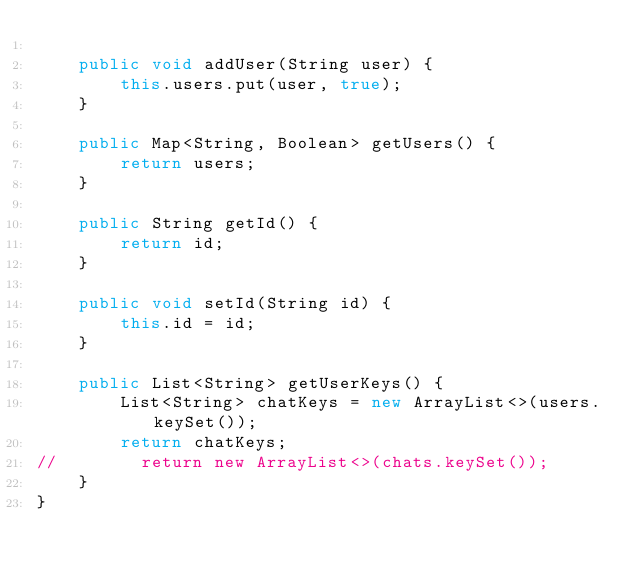Convert code to text. <code><loc_0><loc_0><loc_500><loc_500><_Java_>
    public void addUser(String user) {
        this.users.put(user, true);
    }

    public Map<String, Boolean> getUsers() {
        return users;
    }

    public String getId() {
        return id;
    }

    public void setId(String id) {
        this.id = id;
    }

    public List<String> getUserKeys() {
        List<String> chatKeys = new ArrayList<>(users.keySet());
        return chatKeys;
//        return new ArrayList<>(chats.keySet());
    }
}
</code> 